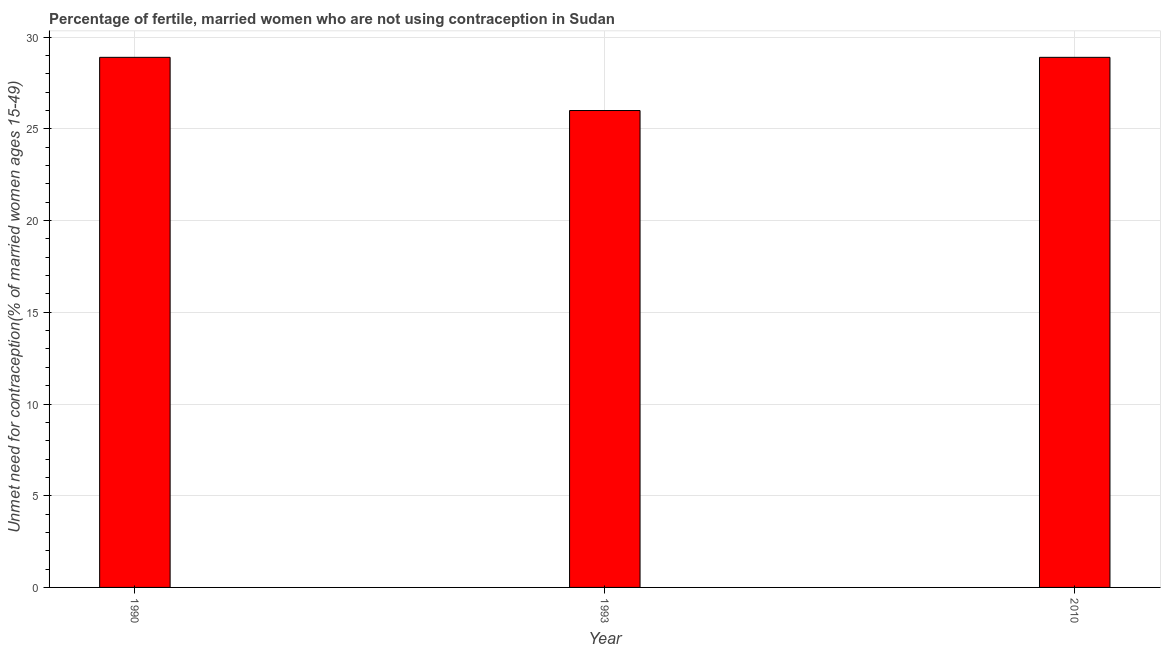What is the title of the graph?
Your answer should be very brief. Percentage of fertile, married women who are not using contraception in Sudan. What is the label or title of the X-axis?
Your answer should be compact. Year. What is the label or title of the Y-axis?
Provide a succinct answer.  Unmet need for contraception(% of married women ages 15-49). What is the number of married women who are not using contraception in 1993?
Your response must be concise. 26. Across all years, what is the maximum number of married women who are not using contraception?
Make the answer very short. 28.9. In which year was the number of married women who are not using contraception maximum?
Offer a very short reply. 1990. In which year was the number of married women who are not using contraception minimum?
Offer a very short reply. 1993. What is the sum of the number of married women who are not using contraception?
Your response must be concise. 83.8. What is the difference between the number of married women who are not using contraception in 1993 and 2010?
Provide a succinct answer. -2.9. What is the average number of married women who are not using contraception per year?
Your answer should be compact. 27.93. What is the median number of married women who are not using contraception?
Ensure brevity in your answer.  28.9. Do a majority of the years between 1990 and 1993 (inclusive) have number of married women who are not using contraception greater than 5 %?
Give a very brief answer. Yes. Is the number of married women who are not using contraception in 1993 less than that in 2010?
Your response must be concise. Yes. What is the difference between the highest and the lowest number of married women who are not using contraception?
Make the answer very short. 2.9. In how many years, is the number of married women who are not using contraception greater than the average number of married women who are not using contraception taken over all years?
Give a very brief answer. 2. What is the difference between two consecutive major ticks on the Y-axis?
Make the answer very short. 5. Are the values on the major ticks of Y-axis written in scientific E-notation?
Your answer should be very brief. No. What is the  Unmet need for contraception(% of married women ages 15-49) in 1990?
Give a very brief answer. 28.9. What is the  Unmet need for contraception(% of married women ages 15-49) of 1993?
Provide a succinct answer. 26. What is the  Unmet need for contraception(% of married women ages 15-49) in 2010?
Your answer should be compact. 28.9. What is the difference between the  Unmet need for contraception(% of married women ages 15-49) in 1990 and 1993?
Ensure brevity in your answer.  2.9. What is the difference between the  Unmet need for contraception(% of married women ages 15-49) in 1990 and 2010?
Ensure brevity in your answer.  0. What is the ratio of the  Unmet need for contraception(% of married women ages 15-49) in 1990 to that in 1993?
Ensure brevity in your answer.  1.11. What is the ratio of the  Unmet need for contraception(% of married women ages 15-49) in 1993 to that in 2010?
Provide a succinct answer. 0.9. 